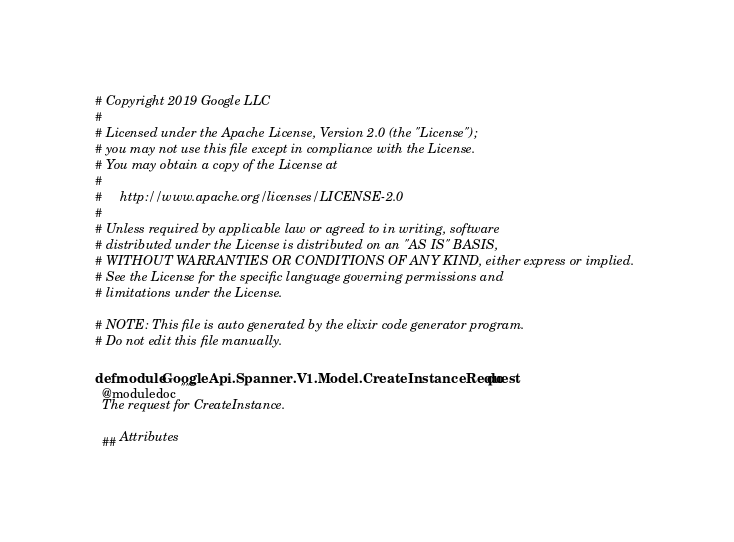<code> <loc_0><loc_0><loc_500><loc_500><_Elixir_># Copyright 2019 Google LLC
#
# Licensed under the Apache License, Version 2.0 (the "License");
# you may not use this file except in compliance with the License.
# You may obtain a copy of the License at
#
#     http://www.apache.org/licenses/LICENSE-2.0
#
# Unless required by applicable law or agreed to in writing, software
# distributed under the License is distributed on an "AS IS" BASIS,
# WITHOUT WARRANTIES OR CONDITIONS OF ANY KIND, either express or implied.
# See the License for the specific language governing permissions and
# limitations under the License.

# NOTE: This file is auto generated by the elixir code generator program.
# Do not edit this file manually.

defmodule GoogleApi.Spanner.V1.Model.CreateInstanceRequest do
  @moduledoc """
  The request for CreateInstance.

  ## Attributes
</code> 